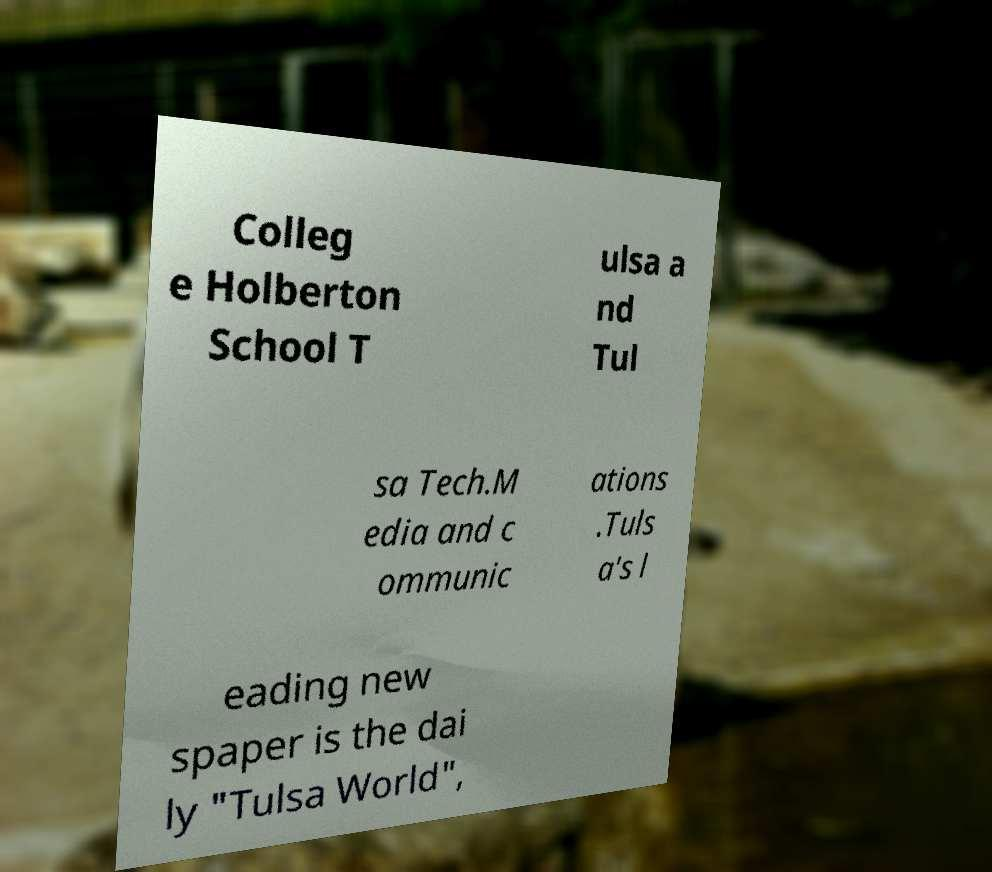Can you read and provide the text displayed in the image?This photo seems to have some interesting text. Can you extract and type it out for me? Colleg e Holberton School T ulsa a nd Tul sa Tech.M edia and c ommunic ations .Tuls a's l eading new spaper is the dai ly "Tulsa World", 